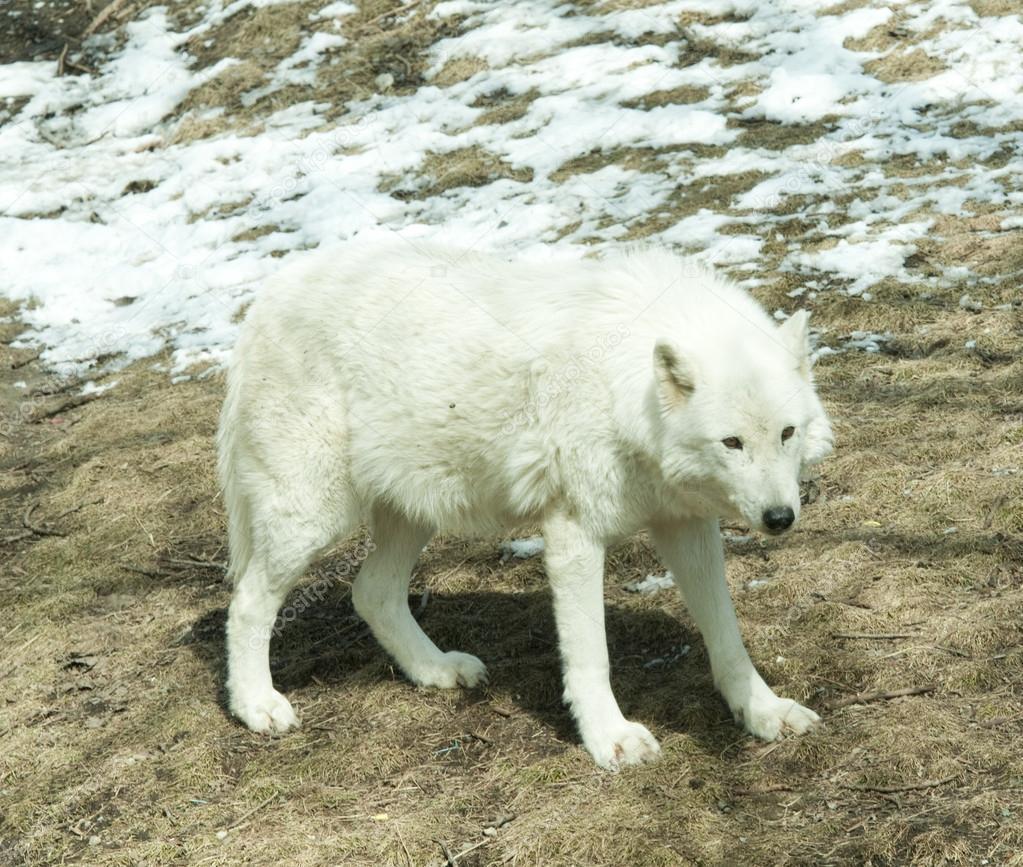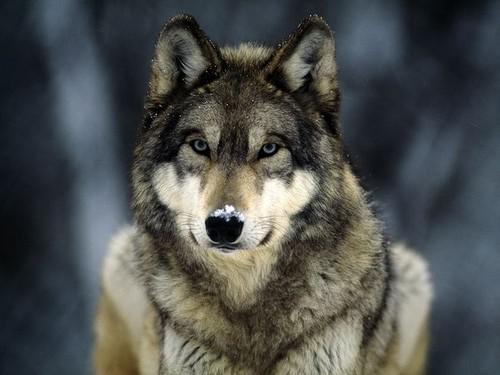The first image is the image on the left, the second image is the image on the right. Considering the images on both sides, is "There is a fence behind the animal in the image on the left." valid? Answer yes or no. No. The first image is the image on the left, the second image is the image on the right. Evaluate the accuracy of this statement regarding the images: "In the left image, wire fence is visible behind the wolf.". Is it true? Answer yes or no. No. 